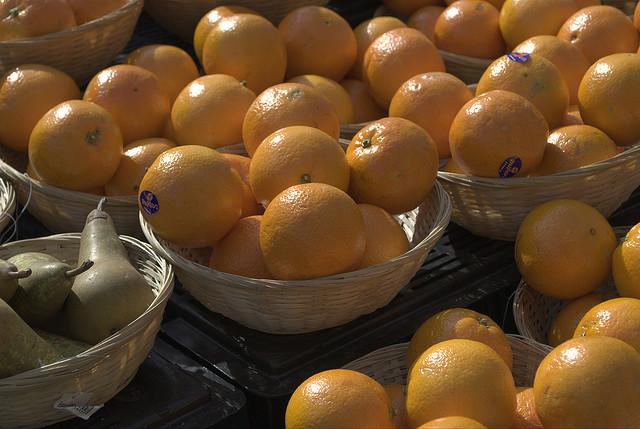What are the tan baskets made out of?

Choices:
A) plastic
B) cotton
C) straw
D) aluminum straw 